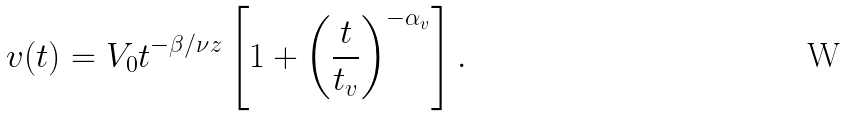Convert formula to latex. <formula><loc_0><loc_0><loc_500><loc_500>v ( t ) = V _ { 0 } t ^ { - \beta / \nu z } \left [ 1 + \left ( \frac { t } { t _ { v } } \right ) ^ { - \alpha _ { v } } \right ] .</formula> 